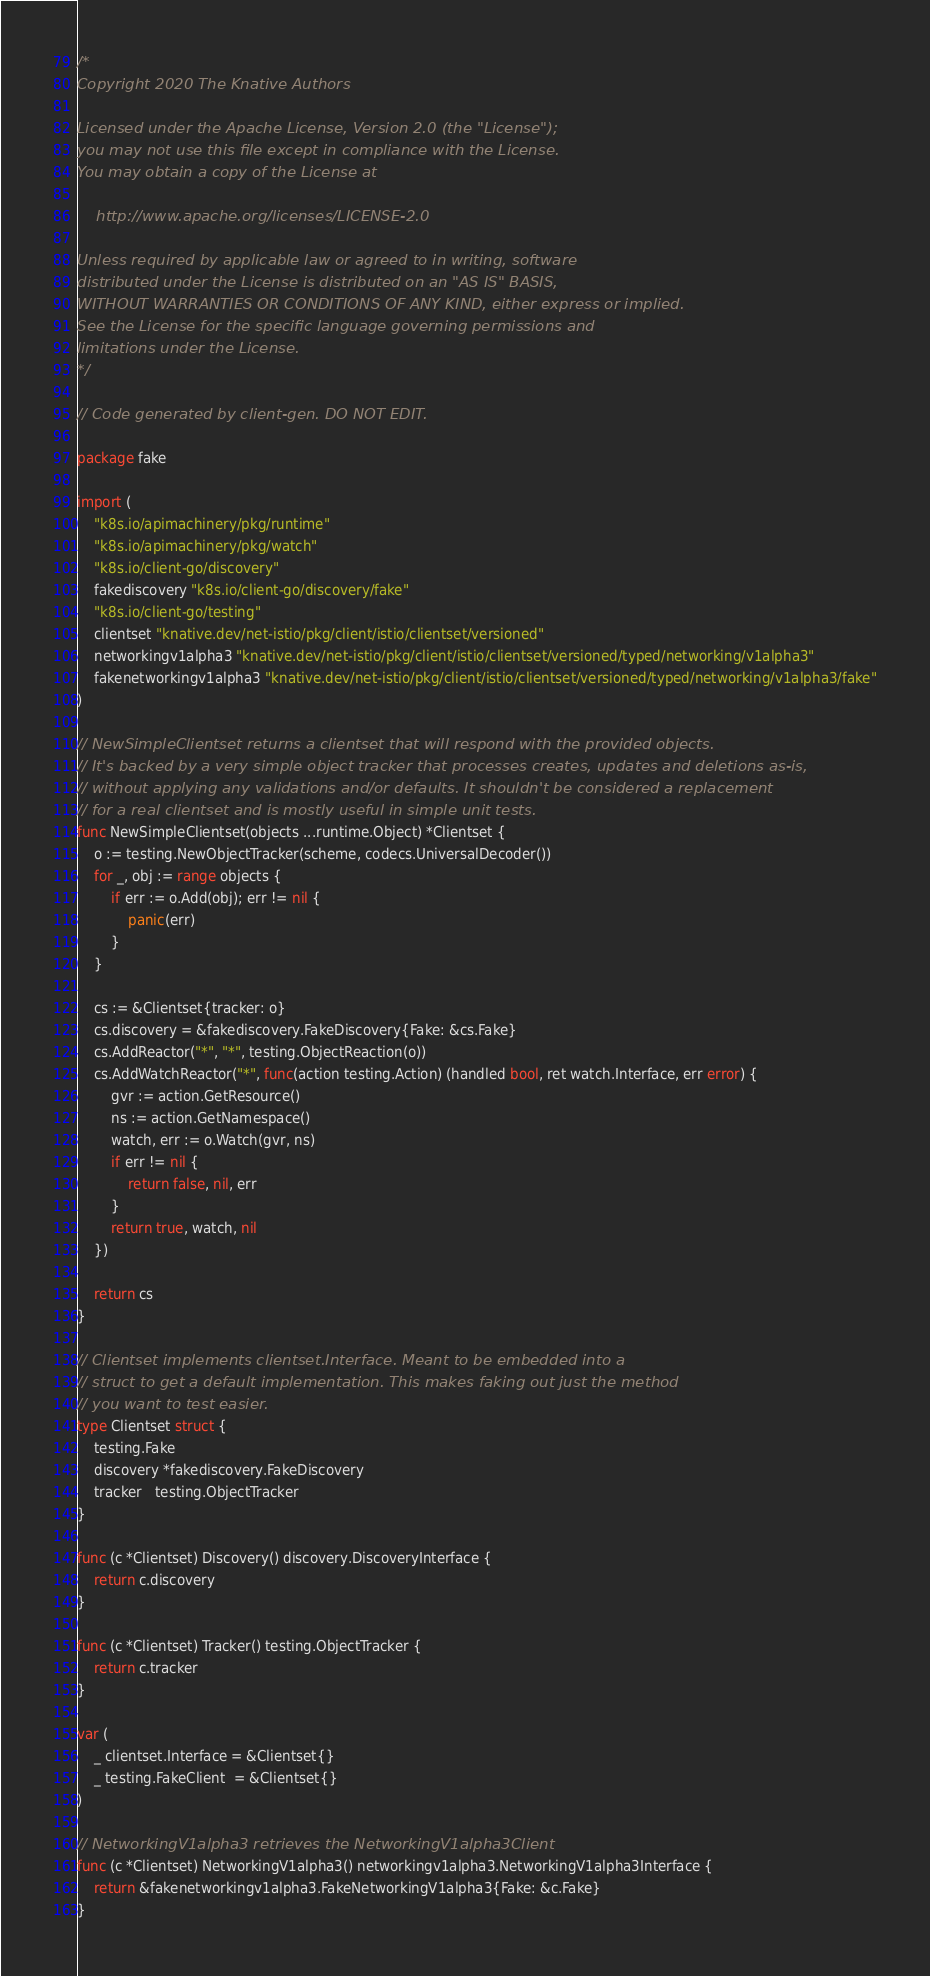Convert code to text. <code><loc_0><loc_0><loc_500><loc_500><_Go_>/*
Copyright 2020 The Knative Authors

Licensed under the Apache License, Version 2.0 (the "License");
you may not use this file except in compliance with the License.
You may obtain a copy of the License at

    http://www.apache.org/licenses/LICENSE-2.0

Unless required by applicable law or agreed to in writing, software
distributed under the License is distributed on an "AS IS" BASIS,
WITHOUT WARRANTIES OR CONDITIONS OF ANY KIND, either express or implied.
See the License for the specific language governing permissions and
limitations under the License.
*/

// Code generated by client-gen. DO NOT EDIT.

package fake

import (
	"k8s.io/apimachinery/pkg/runtime"
	"k8s.io/apimachinery/pkg/watch"
	"k8s.io/client-go/discovery"
	fakediscovery "k8s.io/client-go/discovery/fake"
	"k8s.io/client-go/testing"
	clientset "knative.dev/net-istio/pkg/client/istio/clientset/versioned"
	networkingv1alpha3 "knative.dev/net-istio/pkg/client/istio/clientset/versioned/typed/networking/v1alpha3"
	fakenetworkingv1alpha3 "knative.dev/net-istio/pkg/client/istio/clientset/versioned/typed/networking/v1alpha3/fake"
)

// NewSimpleClientset returns a clientset that will respond with the provided objects.
// It's backed by a very simple object tracker that processes creates, updates and deletions as-is,
// without applying any validations and/or defaults. It shouldn't be considered a replacement
// for a real clientset and is mostly useful in simple unit tests.
func NewSimpleClientset(objects ...runtime.Object) *Clientset {
	o := testing.NewObjectTracker(scheme, codecs.UniversalDecoder())
	for _, obj := range objects {
		if err := o.Add(obj); err != nil {
			panic(err)
		}
	}

	cs := &Clientset{tracker: o}
	cs.discovery = &fakediscovery.FakeDiscovery{Fake: &cs.Fake}
	cs.AddReactor("*", "*", testing.ObjectReaction(o))
	cs.AddWatchReactor("*", func(action testing.Action) (handled bool, ret watch.Interface, err error) {
		gvr := action.GetResource()
		ns := action.GetNamespace()
		watch, err := o.Watch(gvr, ns)
		if err != nil {
			return false, nil, err
		}
		return true, watch, nil
	})

	return cs
}

// Clientset implements clientset.Interface. Meant to be embedded into a
// struct to get a default implementation. This makes faking out just the method
// you want to test easier.
type Clientset struct {
	testing.Fake
	discovery *fakediscovery.FakeDiscovery
	tracker   testing.ObjectTracker
}

func (c *Clientset) Discovery() discovery.DiscoveryInterface {
	return c.discovery
}

func (c *Clientset) Tracker() testing.ObjectTracker {
	return c.tracker
}

var (
	_ clientset.Interface = &Clientset{}
	_ testing.FakeClient  = &Clientset{}
)

// NetworkingV1alpha3 retrieves the NetworkingV1alpha3Client
func (c *Clientset) NetworkingV1alpha3() networkingv1alpha3.NetworkingV1alpha3Interface {
	return &fakenetworkingv1alpha3.FakeNetworkingV1alpha3{Fake: &c.Fake}
}
</code> 